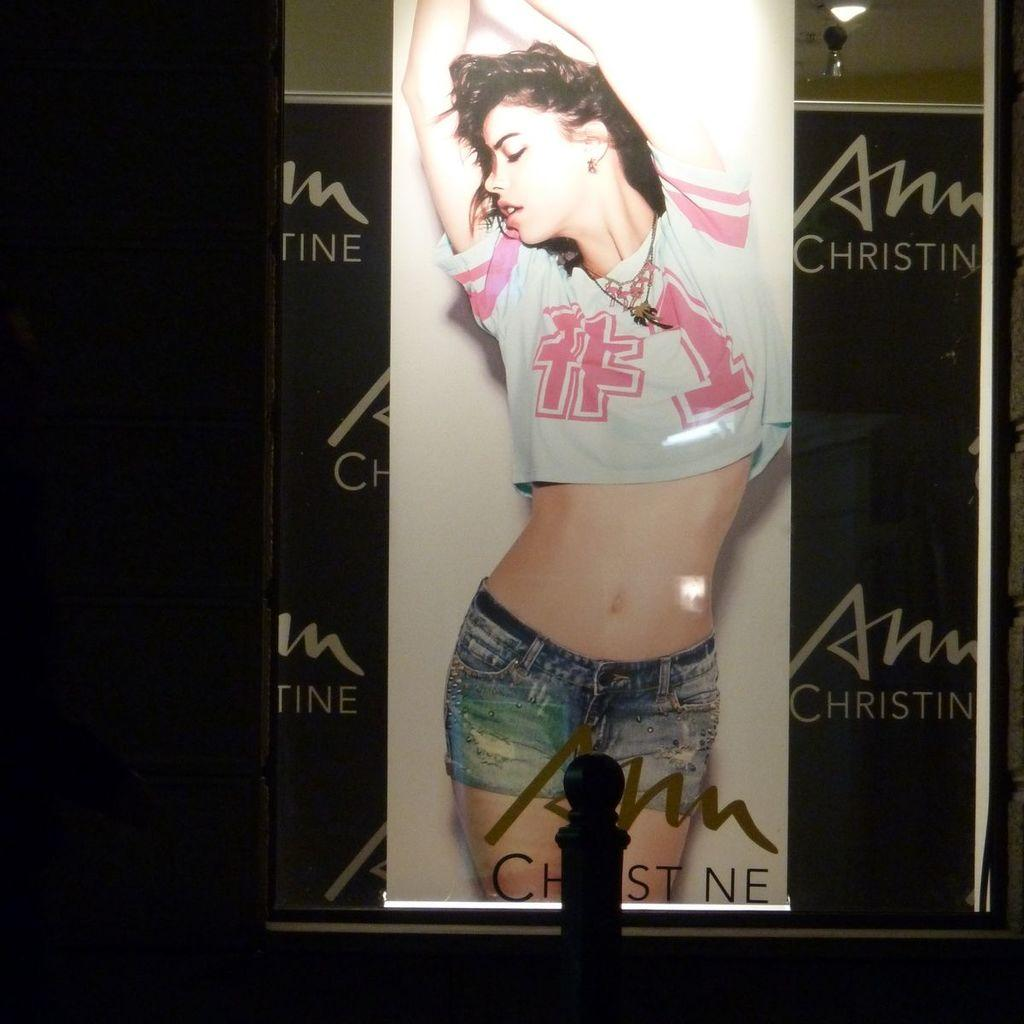Provide a one-sentence caption for the provided image. A women is on an ad with Christin in the right upper corner. 